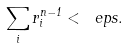Convert formula to latex. <formula><loc_0><loc_0><loc_500><loc_500>\sum _ { i } r _ { i } ^ { n - 1 } < \ e p s .</formula> 